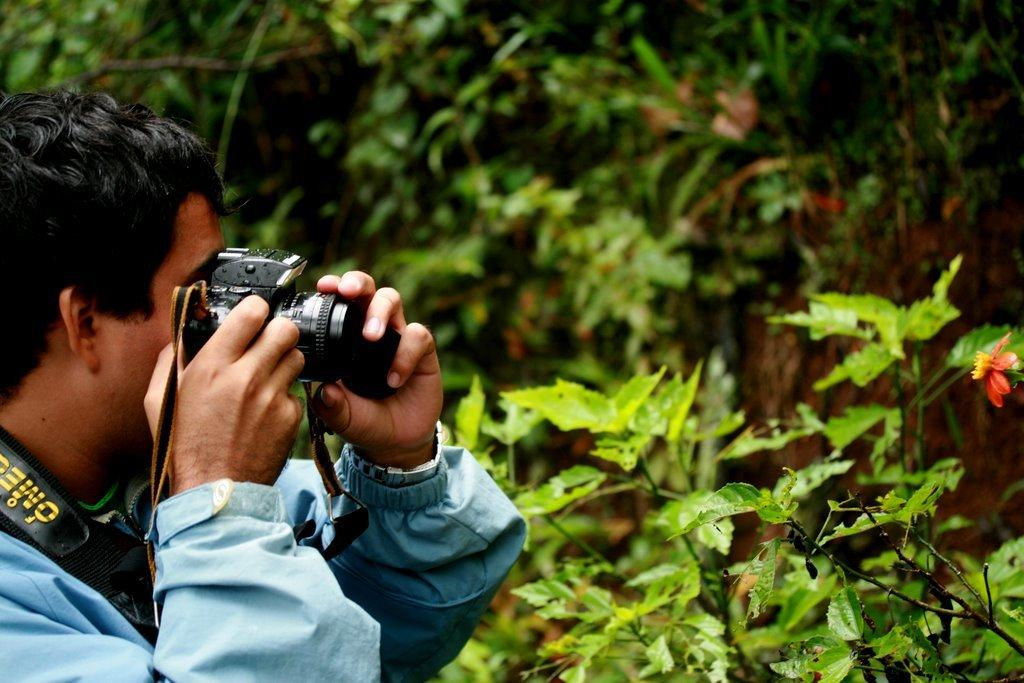What is the main subject of the image? There is a man in the image. What is the man holding in the image? The man is holding a camera. What else can be seen in the image besides the man and the camera? There are plants in the image. What type of banana is growing on the man's head in the image? There is no banana present in the image, nor is there any growth on the man's head. 